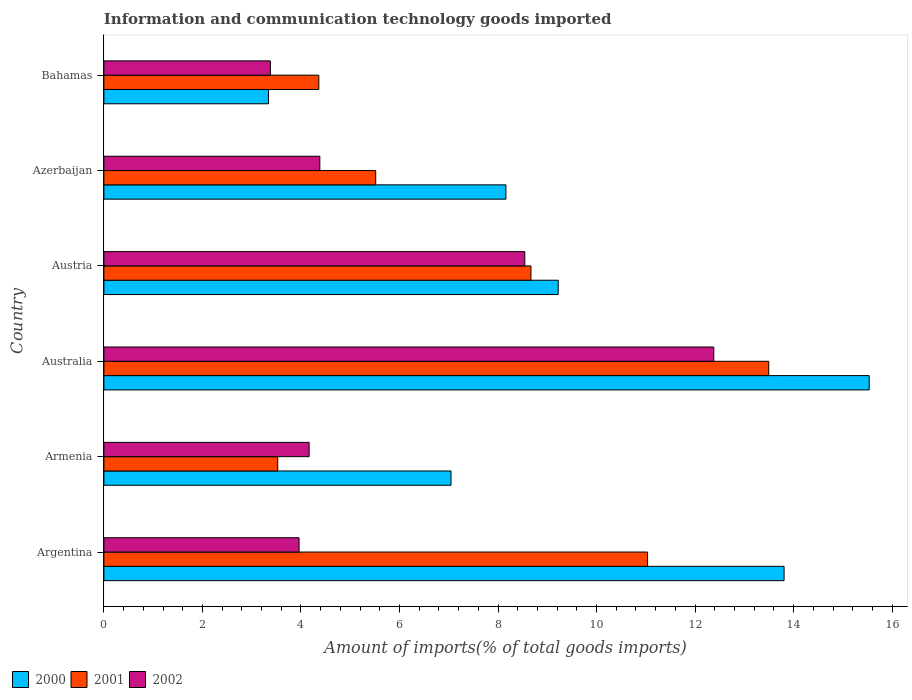How many groups of bars are there?
Ensure brevity in your answer.  6. Are the number of bars per tick equal to the number of legend labels?
Ensure brevity in your answer.  Yes. Are the number of bars on each tick of the Y-axis equal?
Offer a terse response. Yes. How many bars are there on the 6th tick from the bottom?
Offer a terse response. 3. What is the label of the 5th group of bars from the top?
Your answer should be very brief. Armenia. What is the amount of goods imported in 2000 in Argentina?
Provide a short and direct response. 13.81. Across all countries, what is the maximum amount of goods imported in 2000?
Offer a very short reply. 15.53. Across all countries, what is the minimum amount of goods imported in 2002?
Provide a short and direct response. 3.38. In which country was the amount of goods imported in 2002 maximum?
Ensure brevity in your answer.  Australia. In which country was the amount of goods imported in 2000 minimum?
Provide a succinct answer. Bahamas. What is the total amount of goods imported in 2002 in the graph?
Keep it short and to the point. 36.81. What is the difference between the amount of goods imported in 2002 in Argentina and that in Bahamas?
Keep it short and to the point. 0.58. What is the difference between the amount of goods imported in 2000 in Azerbaijan and the amount of goods imported in 2001 in Australia?
Offer a very short reply. -5.33. What is the average amount of goods imported in 2002 per country?
Your response must be concise. 6.14. What is the difference between the amount of goods imported in 2002 and amount of goods imported in 2000 in Australia?
Your answer should be very brief. -3.16. In how many countries, is the amount of goods imported in 2002 greater than 6.8 %?
Your answer should be compact. 2. What is the ratio of the amount of goods imported in 2001 in Armenia to that in Azerbaijan?
Your response must be concise. 0.64. Is the amount of goods imported in 2000 in Australia less than that in Azerbaijan?
Provide a short and direct response. No. What is the difference between the highest and the second highest amount of goods imported in 2001?
Ensure brevity in your answer.  2.46. What is the difference between the highest and the lowest amount of goods imported in 2000?
Your answer should be compact. 12.19. Is the sum of the amount of goods imported in 2002 in Australia and Bahamas greater than the maximum amount of goods imported in 2000 across all countries?
Offer a terse response. Yes. Is it the case that in every country, the sum of the amount of goods imported in 2002 and amount of goods imported in 2001 is greater than the amount of goods imported in 2000?
Provide a short and direct response. Yes. How many bars are there?
Provide a succinct answer. 18. How many countries are there in the graph?
Offer a very short reply. 6. Are the values on the major ticks of X-axis written in scientific E-notation?
Make the answer very short. No. Does the graph contain grids?
Ensure brevity in your answer.  No. How many legend labels are there?
Make the answer very short. 3. What is the title of the graph?
Ensure brevity in your answer.  Information and communication technology goods imported. Does "2006" appear as one of the legend labels in the graph?
Keep it short and to the point. No. What is the label or title of the X-axis?
Your answer should be very brief. Amount of imports(% of total goods imports). What is the label or title of the Y-axis?
Provide a succinct answer. Country. What is the Amount of imports(% of total goods imports) of 2000 in Argentina?
Ensure brevity in your answer.  13.81. What is the Amount of imports(% of total goods imports) in 2001 in Argentina?
Make the answer very short. 11.04. What is the Amount of imports(% of total goods imports) of 2002 in Argentina?
Ensure brevity in your answer.  3.96. What is the Amount of imports(% of total goods imports) of 2000 in Armenia?
Provide a short and direct response. 7.05. What is the Amount of imports(% of total goods imports) of 2001 in Armenia?
Offer a very short reply. 3.53. What is the Amount of imports(% of total goods imports) of 2002 in Armenia?
Your response must be concise. 4.17. What is the Amount of imports(% of total goods imports) in 2000 in Australia?
Keep it short and to the point. 15.53. What is the Amount of imports(% of total goods imports) in 2001 in Australia?
Give a very brief answer. 13.49. What is the Amount of imports(% of total goods imports) in 2002 in Australia?
Your answer should be compact. 12.38. What is the Amount of imports(% of total goods imports) of 2000 in Austria?
Your answer should be very brief. 9.22. What is the Amount of imports(% of total goods imports) in 2001 in Austria?
Keep it short and to the point. 8.67. What is the Amount of imports(% of total goods imports) of 2002 in Austria?
Ensure brevity in your answer.  8.54. What is the Amount of imports(% of total goods imports) of 2000 in Azerbaijan?
Your response must be concise. 8.16. What is the Amount of imports(% of total goods imports) of 2001 in Azerbaijan?
Offer a terse response. 5.52. What is the Amount of imports(% of total goods imports) in 2002 in Azerbaijan?
Ensure brevity in your answer.  4.38. What is the Amount of imports(% of total goods imports) in 2000 in Bahamas?
Ensure brevity in your answer.  3.34. What is the Amount of imports(% of total goods imports) in 2001 in Bahamas?
Keep it short and to the point. 4.36. What is the Amount of imports(% of total goods imports) in 2002 in Bahamas?
Provide a short and direct response. 3.38. Across all countries, what is the maximum Amount of imports(% of total goods imports) of 2000?
Keep it short and to the point. 15.53. Across all countries, what is the maximum Amount of imports(% of total goods imports) in 2001?
Offer a very short reply. 13.49. Across all countries, what is the maximum Amount of imports(% of total goods imports) of 2002?
Provide a succinct answer. 12.38. Across all countries, what is the minimum Amount of imports(% of total goods imports) of 2000?
Your response must be concise. 3.34. Across all countries, what is the minimum Amount of imports(% of total goods imports) of 2001?
Offer a very short reply. 3.53. Across all countries, what is the minimum Amount of imports(% of total goods imports) in 2002?
Provide a short and direct response. 3.38. What is the total Amount of imports(% of total goods imports) of 2000 in the graph?
Your response must be concise. 57.11. What is the total Amount of imports(% of total goods imports) of 2001 in the graph?
Your response must be concise. 46.61. What is the total Amount of imports(% of total goods imports) in 2002 in the graph?
Your response must be concise. 36.81. What is the difference between the Amount of imports(% of total goods imports) of 2000 in Argentina and that in Armenia?
Ensure brevity in your answer.  6.76. What is the difference between the Amount of imports(% of total goods imports) in 2001 in Argentina and that in Armenia?
Provide a short and direct response. 7.51. What is the difference between the Amount of imports(% of total goods imports) in 2002 in Argentina and that in Armenia?
Offer a very short reply. -0.2. What is the difference between the Amount of imports(% of total goods imports) of 2000 in Argentina and that in Australia?
Ensure brevity in your answer.  -1.73. What is the difference between the Amount of imports(% of total goods imports) of 2001 in Argentina and that in Australia?
Give a very brief answer. -2.46. What is the difference between the Amount of imports(% of total goods imports) of 2002 in Argentina and that in Australia?
Offer a terse response. -8.42. What is the difference between the Amount of imports(% of total goods imports) in 2000 in Argentina and that in Austria?
Your answer should be compact. 4.58. What is the difference between the Amount of imports(% of total goods imports) of 2001 in Argentina and that in Austria?
Make the answer very short. 2.37. What is the difference between the Amount of imports(% of total goods imports) in 2002 in Argentina and that in Austria?
Make the answer very short. -4.58. What is the difference between the Amount of imports(% of total goods imports) in 2000 in Argentina and that in Azerbaijan?
Provide a short and direct response. 5.65. What is the difference between the Amount of imports(% of total goods imports) of 2001 in Argentina and that in Azerbaijan?
Provide a short and direct response. 5.52. What is the difference between the Amount of imports(% of total goods imports) in 2002 in Argentina and that in Azerbaijan?
Give a very brief answer. -0.42. What is the difference between the Amount of imports(% of total goods imports) of 2000 in Argentina and that in Bahamas?
Make the answer very short. 10.46. What is the difference between the Amount of imports(% of total goods imports) in 2001 in Argentina and that in Bahamas?
Provide a succinct answer. 6.67. What is the difference between the Amount of imports(% of total goods imports) in 2002 in Argentina and that in Bahamas?
Keep it short and to the point. 0.58. What is the difference between the Amount of imports(% of total goods imports) in 2000 in Armenia and that in Australia?
Offer a terse response. -8.49. What is the difference between the Amount of imports(% of total goods imports) of 2001 in Armenia and that in Australia?
Your answer should be compact. -9.97. What is the difference between the Amount of imports(% of total goods imports) of 2002 in Armenia and that in Australia?
Offer a very short reply. -8.21. What is the difference between the Amount of imports(% of total goods imports) in 2000 in Armenia and that in Austria?
Give a very brief answer. -2.18. What is the difference between the Amount of imports(% of total goods imports) in 2001 in Armenia and that in Austria?
Provide a short and direct response. -5.14. What is the difference between the Amount of imports(% of total goods imports) in 2002 in Armenia and that in Austria?
Your answer should be compact. -4.38. What is the difference between the Amount of imports(% of total goods imports) in 2000 in Armenia and that in Azerbaijan?
Offer a very short reply. -1.11. What is the difference between the Amount of imports(% of total goods imports) in 2001 in Armenia and that in Azerbaijan?
Make the answer very short. -1.99. What is the difference between the Amount of imports(% of total goods imports) of 2002 in Armenia and that in Azerbaijan?
Your response must be concise. -0.22. What is the difference between the Amount of imports(% of total goods imports) of 2000 in Armenia and that in Bahamas?
Your answer should be very brief. 3.7. What is the difference between the Amount of imports(% of total goods imports) of 2001 in Armenia and that in Bahamas?
Offer a very short reply. -0.83. What is the difference between the Amount of imports(% of total goods imports) of 2002 in Armenia and that in Bahamas?
Give a very brief answer. 0.79. What is the difference between the Amount of imports(% of total goods imports) of 2000 in Australia and that in Austria?
Offer a terse response. 6.31. What is the difference between the Amount of imports(% of total goods imports) of 2001 in Australia and that in Austria?
Provide a succinct answer. 4.83. What is the difference between the Amount of imports(% of total goods imports) in 2002 in Australia and that in Austria?
Your answer should be very brief. 3.84. What is the difference between the Amount of imports(% of total goods imports) in 2000 in Australia and that in Azerbaijan?
Give a very brief answer. 7.37. What is the difference between the Amount of imports(% of total goods imports) in 2001 in Australia and that in Azerbaijan?
Your answer should be compact. 7.98. What is the difference between the Amount of imports(% of total goods imports) of 2002 in Australia and that in Azerbaijan?
Keep it short and to the point. 8. What is the difference between the Amount of imports(% of total goods imports) of 2000 in Australia and that in Bahamas?
Provide a short and direct response. 12.19. What is the difference between the Amount of imports(% of total goods imports) of 2001 in Australia and that in Bahamas?
Provide a succinct answer. 9.13. What is the difference between the Amount of imports(% of total goods imports) of 2002 in Australia and that in Bahamas?
Keep it short and to the point. 9. What is the difference between the Amount of imports(% of total goods imports) in 2000 in Austria and that in Azerbaijan?
Your answer should be very brief. 1.06. What is the difference between the Amount of imports(% of total goods imports) of 2001 in Austria and that in Azerbaijan?
Your answer should be compact. 3.15. What is the difference between the Amount of imports(% of total goods imports) of 2002 in Austria and that in Azerbaijan?
Give a very brief answer. 4.16. What is the difference between the Amount of imports(% of total goods imports) in 2000 in Austria and that in Bahamas?
Make the answer very short. 5.88. What is the difference between the Amount of imports(% of total goods imports) of 2001 in Austria and that in Bahamas?
Ensure brevity in your answer.  4.31. What is the difference between the Amount of imports(% of total goods imports) in 2002 in Austria and that in Bahamas?
Ensure brevity in your answer.  5.16. What is the difference between the Amount of imports(% of total goods imports) of 2000 in Azerbaijan and that in Bahamas?
Keep it short and to the point. 4.82. What is the difference between the Amount of imports(% of total goods imports) of 2001 in Azerbaijan and that in Bahamas?
Your response must be concise. 1.15. What is the difference between the Amount of imports(% of total goods imports) of 2002 in Azerbaijan and that in Bahamas?
Give a very brief answer. 1. What is the difference between the Amount of imports(% of total goods imports) in 2000 in Argentina and the Amount of imports(% of total goods imports) in 2001 in Armenia?
Ensure brevity in your answer.  10.28. What is the difference between the Amount of imports(% of total goods imports) of 2000 in Argentina and the Amount of imports(% of total goods imports) of 2002 in Armenia?
Offer a terse response. 9.64. What is the difference between the Amount of imports(% of total goods imports) of 2001 in Argentina and the Amount of imports(% of total goods imports) of 2002 in Armenia?
Provide a short and direct response. 6.87. What is the difference between the Amount of imports(% of total goods imports) of 2000 in Argentina and the Amount of imports(% of total goods imports) of 2001 in Australia?
Offer a terse response. 0.31. What is the difference between the Amount of imports(% of total goods imports) in 2000 in Argentina and the Amount of imports(% of total goods imports) in 2002 in Australia?
Your answer should be compact. 1.43. What is the difference between the Amount of imports(% of total goods imports) in 2001 in Argentina and the Amount of imports(% of total goods imports) in 2002 in Australia?
Give a very brief answer. -1.34. What is the difference between the Amount of imports(% of total goods imports) in 2000 in Argentina and the Amount of imports(% of total goods imports) in 2001 in Austria?
Your response must be concise. 5.14. What is the difference between the Amount of imports(% of total goods imports) in 2000 in Argentina and the Amount of imports(% of total goods imports) in 2002 in Austria?
Your response must be concise. 5.26. What is the difference between the Amount of imports(% of total goods imports) in 2001 in Argentina and the Amount of imports(% of total goods imports) in 2002 in Austria?
Your answer should be very brief. 2.49. What is the difference between the Amount of imports(% of total goods imports) of 2000 in Argentina and the Amount of imports(% of total goods imports) of 2001 in Azerbaijan?
Provide a short and direct response. 8.29. What is the difference between the Amount of imports(% of total goods imports) in 2000 in Argentina and the Amount of imports(% of total goods imports) in 2002 in Azerbaijan?
Provide a short and direct response. 9.42. What is the difference between the Amount of imports(% of total goods imports) of 2001 in Argentina and the Amount of imports(% of total goods imports) of 2002 in Azerbaijan?
Offer a very short reply. 6.65. What is the difference between the Amount of imports(% of total goods imports) of 2000 in Argentina and the Amount of imports(% of total goods imports) of 2001 in Bahamas?
Ensure brevity in your answer.  9.44. What is the difference between the Amount of imports(% of total goods imports) of 2000 in Argentina and the Amount of imports(% of total goods imports) of 2002 in Bahamas?
Your answer should be very brief. 10.43. What is the difference between the Amount of imports(% of total goods imports) in 2001 in Argentina and the Amount of imports(% of total goods imports) in 2002 in Bahamas?
Ensure brevity in your answer.  7.66. What is the difference between the Amount of imports(% of total goods imports) of 2000 in Armenia and the Amount of imports(% of total goods imports) of 2001 in Australia?
Offer a very short reply. -6.45. What is the difference between the Amount of imports(% of total goods imports) of 2000 in Armenia and the Amount of imports(% of total goods imports) of 2002 in Australia?
Offer a terse response. -5.33. What is the difference between the Amount of imports(% of total goods imports) of 2001 in Armenia and the Amount of imports(% of total goods imports) of 2002 in Australia?
Your answer should be very brief. -8.85. What is the difference between the Amount of imports(% of total goods imports) of 2000 in Armenia and the Amount of imports(% of total goods imports) of 2001 in Austria?
Make the answer very short. -1.62. What is the difference between the Amount of imports(% of total goods imports) in 2000 in Armenia and the Amount of imports(% of total goods imports) in 2002 in Austria?
Provide a short and direct response. -1.5. What is the difference between the Amount of imports(% of total goods imports) in 2001 in Armenia and the Amount of imports(% of total goods imports) in 2002 in Austria?
Provide a short and direct response. -5.01. What is the difference between the Amount of imports(% of total goods imports) in 2000 in Armenia and the Amount of imports(% of total goods imports) in 2001 in Azerbaijan?
Provide a succinct answer. 1.53. What is the difference between the Amount of imports(% of total goods imports) of 2000 in Armenia and the Amount of imports(% of total goods imports) of 2002 in Azerbaijan?
Offer a very short reply. 2.66. What is the difference between the Amount of imports(% of total goods imports) of 2001 in Armenia and the Amount of imports(% of total goods imports) of 2002 in Azerbaijan?
Provide a succinct answer. -0.85. What is the difference between the Amount of imports(% of total goods imports) of 2000 in Armenia and the Amount of imports(% of total goods imports) of 2001 in Bahamas?
Give a very brief answer. 2.68. What is the difference between the Amount of imports(% of total goods imports) of 2000 in Armenia and the Amount of imports(% of total goods imports) of 2002 in Bahamas?
Provide a short and direct response. 3.67. What is the difference between the Amount of imports(% of total goods imports) of 2001 in Armenia and the Amount of imports(% of total goods imports) of 2002 in Bahamas?
Ensure brevity in your answer.  0.15. What is the difference between the Amount of imports(% of total goods imports) in 2000 in Australia and the Amount of imports(% of total goods imports) in 2001 in Austria?
Make the answer very short. 6.87. What is the difference between the Amount of imports(% of total goods imports) of 2000 in Australia and the Amount of imports(% of total goods imports) of 2002 in Austria?
Provide a succinct answer. 6.99. What is the difference between the Amount of imports(% of total goods imports) in 2001 in Australia and the Amount of imports(% of total goods imports) in 2002 in Austria?
Provide a succinct answer. 4.95. What is the difference between the Amount of imports(% of total goods imports) of 2000 in Australia and the Amount of imports(% of total goods imports) of 2001 in Azerbaijan?
Provide a short and direct response. 10.02. What is the difference between the Amount of imports(% of total goods imports) in 2000 in Australia and the Amount of imports(% of total goods imports) in 2002 in Azerbaijan?
Offer a terse response. 11.15. What is the difference between the Amount of imports(% of total goods imports) in 2001 in Australia and the Amount of imports(% of total goods imports) in 2002 in Azerbaijan?
Offer a terse response. 9.11. What is the difference between the Amount of imports(% of total goods imports) in 2000 in Australia and the Amount of imports(% of total goods imports) in 2001 in Bahamas?
Provide a succinct answer. 11.17. What is the difference between the Amount of imports(% of total goods imports) in 2000 in Australia and the Amount of imports(% of total goods imports) in 2002 in Bahamas?
Give a very brief answer. 12.15. What is the difference between the Amount of imports(% of total goods imports) of 2001 in Australia and the Amount of imports(% of total goods imports) of 2002 in Bahamas?
Make the answer very short. 10.11. What is the difference between the Amount of imports(% of total goods imports) of 2000 in Austria and the Amount of imports(% of total goods imports) of 2001 in Azerbaijan?
Provide a short and direct response. 3.7. What is the difference between the Amount of imports(% of total goods imports) of 2000 in Austria and the Amount of imports(% of total goods imports) of 2002 in Azerbaijan?
Provide a succinct answer. 4.84. What is the difference between the Amount of imports(% of total goods imports) in 2001 in Austria and the Amount of imports(% of total goods imports) in 2002 in Azerbaijan?
Keep it short and to the point. 4.29. What is the difference between the Amount of imports(% of total goods imports) in 2000 in Austria and the Amount of imports(% of total goods imports) in 2001 in Bahamas?
Keep it short and to the point. 4.86. What is the difference between the Amount of imports(% of total goods imports) in 2000 in Austria and the Amount of imports(% of total goods imports) in 2002 in Bahamas?
Offer a very short reply. 5.84. What is the difference between the Amount of imports(% of total goods imports) in 2001 in Austria and the Amount of imports(% of total goods imports) in 2002 in Bahamas?
Offer a terse response. 5.29. What is the difference between the Amount of imports(% of total goods imports) in 2000 in Azerbaijan and the Amount of imports(% of total goods imports) in 2001 in Bahamas?
Provide a short and direct response. 3.8. What is the difference between the Amount of imports(% of total goods imports) in 2000 in Azerbaijan and the Amount of imports(% of total goods imports) in 2002 in Bahamas?
Keep it short and to the point. 4.78. What is the difference between the Amount of imports(% of total goods imports) in 2001 in Azerbaijan and the Amount of imports(% of total goods imports) in 2002 in Bahamas?
Ensure brevity in your answer.  2.14. What is the average Amount of imports(% of total goods imports) of 2000 per country?
Provide a succinct answer. 9.52. What is the average Amount of imports(% of total goods imports) in 2001 per country?
Your answer should be very brief. 7.77. What is the average Amount of imports(% of total goods imports) of 2002 per country?
Provide a short and direct response. 6.14. What is the difference between the Amount of imports(% of total goods imports) of 2000 and Amount of imports(% of total goods imports) of 2001 in Argentina?
Give a very brief answer. 2.77. What is the difference between the Amount of imports(% of total goods imports) in 2000 and Amount of imports(% of total goods imports) in 2002 in Argentina?
Make the answer very short. 9.84. What is the difference between the Amount of imports(% of total goods imports) of 2001 and Amount of imports(% of total goods imports) of 2002 in Argentina?
Your response must be concise. 7.07. What is the difference between the Amount of imports(% of total goods imports) in 2000 and Amount of imports(% of total goods imports) in 2001 in Armenia?
Your answer should be compact. 3.52. What is the difference between the Amount of imports(% of total goods imports) of 2000 and Amount of imports(% of total goods imports) of 2002 in Armenia?
Keep it short and to the point. 2.88. What is the difference between the Amount of imports(% of total goods imports) in 2001 and Amount of imports(% of total goods imports) in 2002 in Armenia?
Give a very brief answer. -0.64. What is the difference between the Amount of imports(% of total goods imports) in 2000 and Amount of imports(% of total goods imports) in 2001 in Australia?
Your response must be concise. 2.04. What is the difference between the Amount of imports(% of total goods imports) in 2000 and Amount of imports(% of total goods imports) in 2002 in Australia?
Ensure brevity in your answer.  3.16. What is the difference between the Amount of imports(% of total goods imports) of 2001 and Amount of imports(% of total goods imports) of 2002 in Australia?
Give a very brief answer. 1.12. What is the difference between the Amount of imports(% of total goods imports) in 2000 and Amount of imports(% of total goods imports) in 2001 in Austria?
Make the answer very short. 0.55. What is the difference between the Amount of imports(% of total goods imports) in 2000 and Amount of imports(% of total goods imports) in 2002 in Austria?
Ensure brevity in your answer.  0.68. What is the difference between the Amount of imports(% of total goods imports) in 2001 and Amount of imports(% of total goods imports) in 2002 in Austria?
Give a very brief answer. 0.13. What is the difference between the Amount of imports(% of total goods imports) in 2000 and Amount of imports(% of total goods imports) in 2001 in Azerbaijan?
Provide a short and direct response. 2.64. What is the difference between the Amount of imports(% of total goods imports) of 2000 and Amount of imports(% of total goods imports) of 2002 in Azerbaijan?
Offer a terse response. 3.78. What is the difference between the Amount of imports(% of total goods imports) of 2001 and Amount of imports(% of total goods imports) of 2002 in Azerbaijan?
Provide a short and direct response. 1.13. What is the difference between the Amount of imports(% of total goods imports) of 2000 and Amount of imports(% of total goods imports) of 2001 in Bahamas?
Your answer should be very brief. -1.02. What is the difference between the Amount of imports(% of total goods imports) of 2000 and Amount of imports(% of total goods imports) of 2002 in Bahamas?
Make the answer very short. -0.04. What is the difference between the Amount of imports(% of total goods imports) of 2001 and Amount of imports(% of total goods imports) of 2002 in Bahamas?
Give a very brief answer. 0.98. What is the ratio of the Amount of imports(% of total goods imports) in 2000 in Argentina to that in Armenia?
Your response must be concise. 1.96. What is the ratio of the Amount of imports(% of total goods imports) of 2001 in Argentina to that in Armenia?
Provide a succinct answer. 3.13. What is the ratio of the Amount of imports(% of total goods imports) of 2002 in Argentina to that in Armenia?
Offer a terse response. 0.95. What is the ratio of the Amount of imports(% of total goods imports) in 2000 in Argentina to that in Australia?
Your answer should be compact. 0.89. What is the ratio of the Amount of imports(% of total goods imports) in 2001 in Argentina to that in Australia?
Ensure brevity in your answer.  0.82. What is the ratio of the Amount of imports(% of total goods imports) in 2002 in Argentina to that in Australia?
Your answer should be very brief. 0.32. What is the ratio of the Amount of imports(% of total goods imports) of 2000 in Argentina to that in Austria?
Keep it short and to the point. 1.5. What is the ratio of the Amount of imports(% of total goods imports) in 2001 in Argentina to that in Austria?
Give a very brief answer. 1.27. What is the ratio of the Amount of imports(% of total goods imports) in 2002 in Argentina to that in Austria?
Keep it short and to the point. 0.46. What is the ratio of the Amount of imports(% of total goods imports) of 2000 in Argentina to that in Azerbaijan?
Offer a very short reply. 1.69. What is the ratio of the Amount of imports(% of total goods imports) in 2001 in Argentina to that in Azerbaijan?
Ensure brevity in your answer.  2. What is the ratio of the Amount of imports(% of total goods imports) of 2002 in Argentina to that in Azerbaijan?
Your answer should be compact. 0.9. What is the ratio of the Amount of imports(% of total goods imports) in 2000 in Argentina to that in Bahamas?
Provide a succinct answer. 4.13. What is the ratio of the Amount of imports(% of total goods imports) of 2001 in Argentina to that in Bahamas?
Give a very brief answer. 2.53. What is the ratio of the Amount of imports(% of total goods imports) of 2002 in Argentina to that in Bahamas?
Make the answer very short. 1.17. What is the ratio of the Amount of imports(% of total goods imports) of 2000 in Armenia to that in Australia?
Make the answer very short. 0.45. What is the ratio of the Amount of imports(% of total goods imports) in 2001 in Armenia to that in Australia?
Provide a short and direct response. 0.26. What is the ratio of the Amount of imports(% of total goods imports) of 2002 in Armenia to that in Australia?
Provide a short and direct response. 0.34. What is the ratio of the Amount of imports(% of total goods imports) of 2000 in Armenia to that in Austria?
Provide a short and direct response. 0.76. What is the ratio of the Amount of imports(% of total goods imports) of 2001 in Armenia to that in Austria?
Provide a succinct answer. 0.41. What is the ratio of the Amount of imports(% of total goods imports) in 2002 in Armenia to that in Austria?
Offer a terse response. 0.49. What is the ratio of the Amount of imports(% of total goods imports) of 2000 in Armenia to that in Azerbaijan?
Make the answer very short. 0.86. What is the ratio of the Amount of imports(% of total goods imports) in 2001 in Armenia to that in Azerbaijan?
Keep it short and to the point. 0.64. What is the ratio of the Amount of imports(% of total goods imports) in 2002 in Armenia to that in Azerbaijan?
Offer a terse response. 0.95. What is the ratio of the Amount of imports(% of total goods imports) of 2000 in Armenia to that in Bahamas?
Keep it short and to the point. 2.11. What is the ratio of the Amount of imports(% of total goods imports) of 2001 in Armenia to that in Bahamas?
Your answer should be compact. 0.81. What is the ratio of the Amount of imports(% of total goods imports) in 2002 in Armenia to that in Bahamas?
Keep it short and to the point. 1.23. What is the ratio of the Amount of imports(% of total goods imports) in 2000 in Australia to that in Austria?
Your response must be concise. 1.68. What is the ratio of the Amount of imports(% of total goods imports) in 2001 in Australia to that in Austria?
Make the answer very short. 1.56. What is the ratio of the Amount of imports(% of total goods imports) of 2002 in Australia to that in Austria?
Your answer should be compact. 1.45. What is the ratio of the Amount of imports(% of total goods imports) of 2000 in Australia to that in Azerbaijan?
Offer a very short reply. 1.9. What is the ratio of the Amount of imports(% of total goods imports) in 2001 in Australia to that in Azerbaijan?
Offer a terse response. 2.45. What is the ratio of the Amount of imports(% of total goods imports) in 2002 in Australia to that in Azerbaijan?
Your answer should be very brief. 2.82. What is the ratio of the Amount of imports(% of total goods imports) of 2000 in Australia to that in Bahamas?
Provide a succinct answer. 4.65. What is the ratio of the Amount of imports(% of total goods imports) of 2001 in Australia to that in Bahamas?
Offer a very short reply. 3.09. What is the ratio of the Amount of imports(% of total goods imports) of 2002 in Australia to that in Bahamas?
Offer a terse response. 3.66. What is the ratio of the Amount of imports(% of total goods imports) of 2000 in Austria to that in Azerbaijan?
Your answer should be very brief. 1.13. What is the ratio of the Amount of imports(% of total goods imports) of 2001 in Austria to that in Azerbaijan?
Provide a succinct answer. 1.57. What is the ratio of the Amount of imports(% of total goods imports) in 2002 in Austria to that in Azerbaijan?
Offer a very short reply. 1.95. What is the ratio of the Amount of imports(% of total goods imports) in 2000 in Austria to that in Bahamas?
Offer a terse response. 2.76. What is the ratio of the Amount of imports(% of total goods imports) of 2001 in Austria to that in Bahamas?
Give a very brief answer. 1.99. What is the ratio of the Amount of imports(% of total goods imports) of 2002 in Austria to that in Bahamas?
Your answer should be compact. 2.53. What is the ratio of the Amount of imports(% of total goods imports) in 2000 in Azerbaijan to that in Bahamas?
Offer a terse response. 2.44. What is the ratio of the Amount of imports(% of total goods imports) of 2001 in Azerbaijan to that in Bahamas?
Provide a short and direct response. 1.26. What is the ratio of the Amount of imports(% of total goods imports) of 2002 in Azerbaijan to that in Bahamas?
Offer a terse response. 1.3. What is the difference between the highest and the second highest Amount of imports(% of total goods imports) of 2000?
Offer a terse response. 1.73. What is the difference between the highest and the second highest Amount of imports(% of total goods imports) of 2001?
Offer a terse response. 2.46. What is the difference between the highest and the second highest Amount of imports(% of total goods imports) of 2002?
Your response must be concise. 3.84. What is the difference between the highest and the lowest Amount of imports(% of total goods imports) in 2000?
Make the answer very short. 12.19. What is the difference between the highest and the lowest Amount of imports(% of total goods imports) of 2001?
Offer a terse response. 9.97. What is the difference between the highest and the lowest Amount of imports(% of total goods imports) in 2002?
Make the answer very short. 9. 